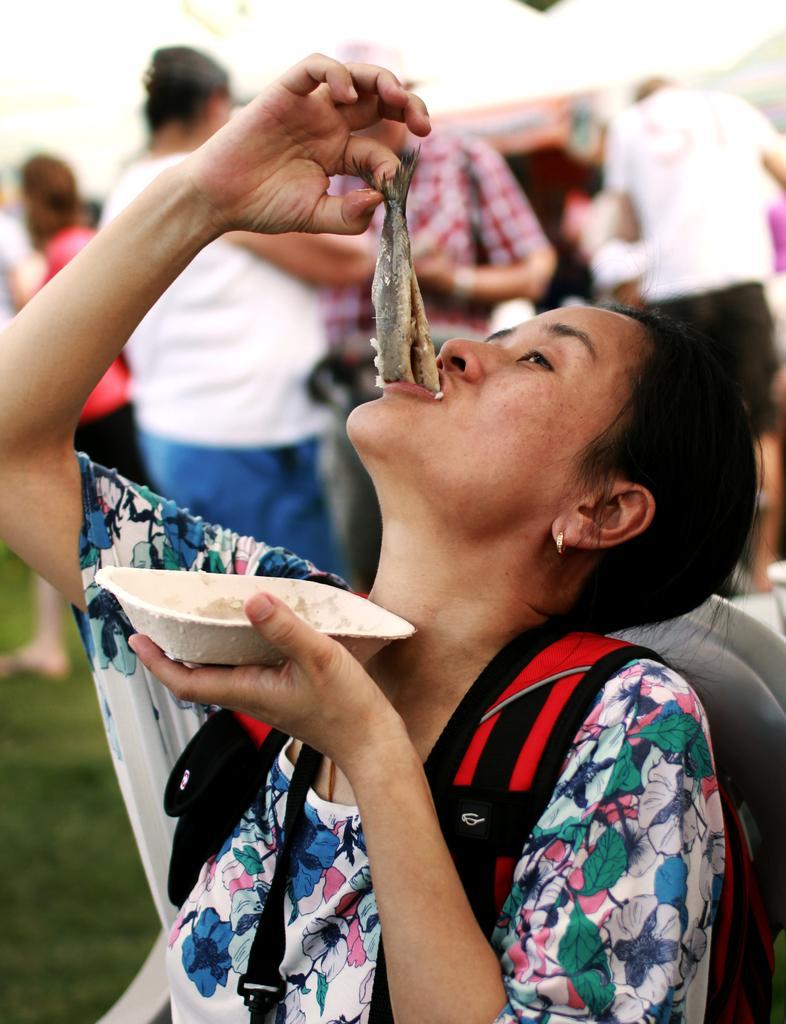Describe this image in one or two sentences. In the image I can see a lady who is wearing the back pack and eating the food item and also I can see some other people to the side. 